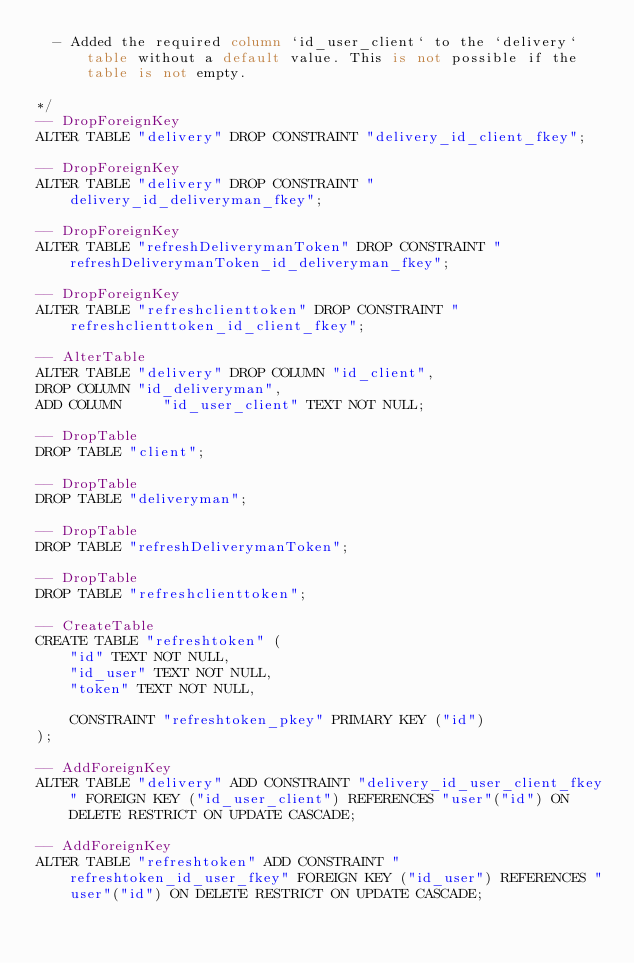Convert code to text. <code><loc_0><loc_0><loc_500><loc_500><_SQL_>  - Added the required column `id_user_client` to the `delivery` table without a default value. This is not possible if the table is not empty.

*/
-- DropForeignKey
ALTER TABLE "delivery" DROP CONSTRAINT "delivery_id_client_fkey";

-- DropForeignKey
ALTER TABLE "delivery" DROP CONSTRAINT "delivery_id_deliveryman_fkey";

-- DropForeignKey
ALTER TABLE "refreshDeliverymanToken" DROP CONSTRAINT "refreshDeliverymanToken_id_deliveryman_fkey";

-- DropForeignKey
ALTER TABLE "refreshclienttoken" DROP CONSTRAINT "refreshclienttoken_id_client_fkey";

-- AlterTable
ALTER TABLE "delivery" DROP COLUMN "id_client",
DROP COLUMN "id_deliveryman",
ADD COLUMN     "id_user_client" TEXT NOT NULL;

-- DropTable
DROP TABLE "client";

-- DropTable
DROP TABLE "deliveryman";

-- DropTable
DROP TABLE "refreshDeliverymanToken";

-- DropTable
DROP TABLE "refreshclienttoken";

-- CreateTable
CREATE TABLE "refreshtoken" (
    "id" TEXT NOT NULL,
    "id_user" TEXT NOT NULL,
    "token" TEXT NOT NULL,

    CONSTRAINT "refreshtoken_pkey" PRIMARY KEY ("id")
);

-- AddForeignKey
ALTER TABLE "delivery" ADD CONSTRAINT "delivery_id_user_client_fkey" FOREIGN KEY ("id_user_client") REFERENCES "user"("id") ON DELETE RESTRICT ON UPDATE CASCADE;

-- AddForeignKey
ALTER TABLE "refreshtoken" ADD CONSTRAINT "refreshtoken_id_user_fkey" FOREIGN KEY ("id_user") REFERENCES "user"("id") ON DELETE RESTRICT ON UPDATE CASCADE;
</code> 